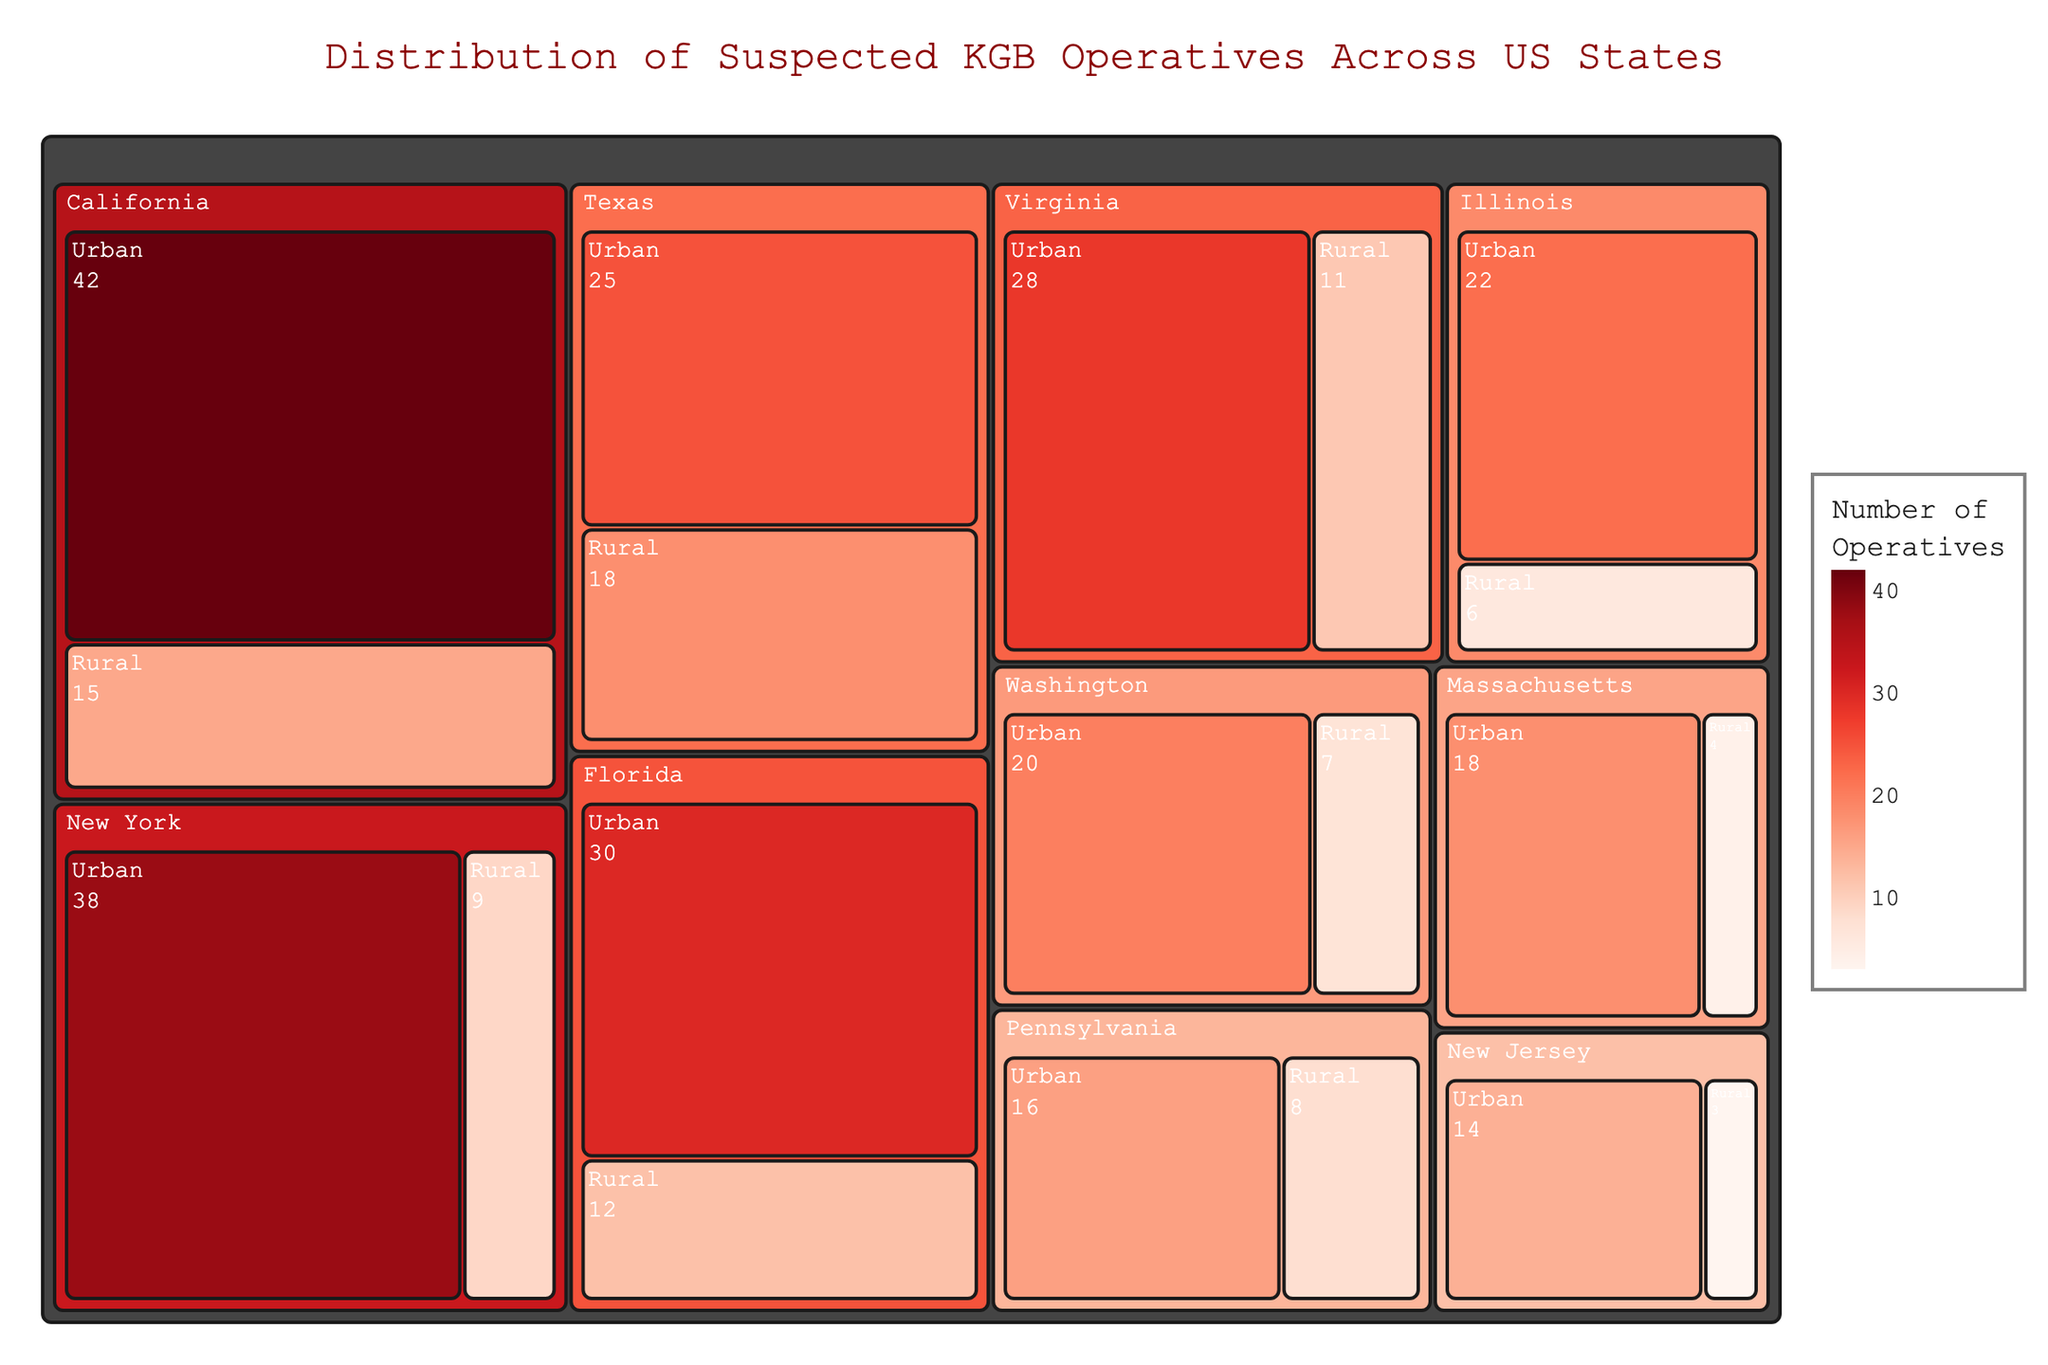What is the total number of suspected operatives in California? To find the total, look at the numbers from both urban and rural areas in California. Sum them up: 42 (Urban) + 15 (Rural) = 57.
Answer: 57 Which state has the highest number of suspected operatives? The treemap represents suspected operatives by each state. The state with the largest combined area of urban and rural cells has the most operatives. California, with 57 operatives, has the largest total.
Answer: California How many more suspected operatives are there in Texas urban areas compared to Texas rural areas? Identify the numbers for Texas: 25 in urban and 18 in rural. Subtract the rural operatives from the urban ones: 25 - 18 = 7.
Answer: 7 Which state has the smallest number of suspected operatives in rural areas? Locate the values for rural areas and find the smallest one. New Jersey has only 3 suspected operatives in rural areas, the lowest among all states.
Answer: New Jersey What is the color of the urban cells for states with the highest number of suspected operatives? The color indicates the number of operatives with a scale from light to dark red. California, having the highest operatives, will have the darkest red in its urban cell.
Answer: Dark Red What is the difference between the total number of operatives in New York and Florida? Sum the suspected operatives in New York (38 Urban + 9 Rural) and Florida (30 Urban + 12 Rural). New York has a total of 47, and Florida has 42. The difference is 47 - 42 = 5.
Answer: 5 How many states have more suspected operatives in urban areas than in rural areas? Compare values for urban and rural areas in each state. All states (California, New York, Texas, Florida, Washington, Illinois, Massachusetts, Virginia, Pennsylvania, New Jersey) have more operatives in urban areas. Thus, all 10 states fall into this criteria.
Answer: 10 Which state has the closest number of suspected operatives in urban and rural areas? Compare the difference for each state. Texas has 25 (Urban) and 18 (Rural), with a difference of 7, which is the smallest difference among all states.
Answer: Texas How many suspected operatives are there across all states? Sum the total number of operatives from all states. The sum is the total for all states: 57 + 47 + 43 + 42 + 27 + 28 + 22 + 32 + 24 + 17 = 339.
Answer: 339 Which state has the highest number of suspected operatives in rural areas? Check the figure for the highest value in rural cells. Texas has 18 rural operatives, the highest among the rural areas shown.
Answer: Texas 